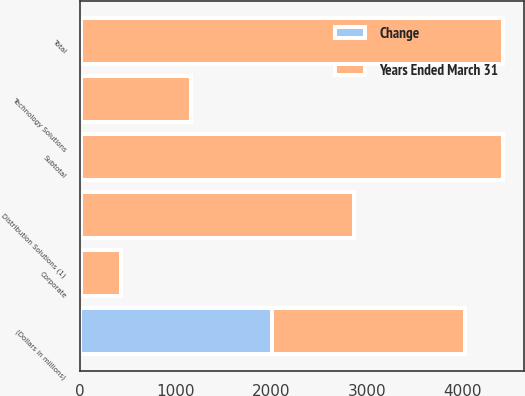Convert chart. <chart><loc_0><loc_0><loc_500><loc_500><stacked_bar_chart><ecel><fcel>(Dollars in millions)<fcel>Distribution Solutions (1)<fcel>Technology Solutions<fcel>Corporate<fcel>Subtotal<fcel>Total<nl><fcel>Years Ended March 31<fcel>2012<fcel>2854<fcel>1151<fcel>413<fcel>4418<fcel>4418<nl><fcel>Change<fcel>2012<fcel>7<fcel>4<fcel>12<fcel>6<fcel>6<nl></chart> 